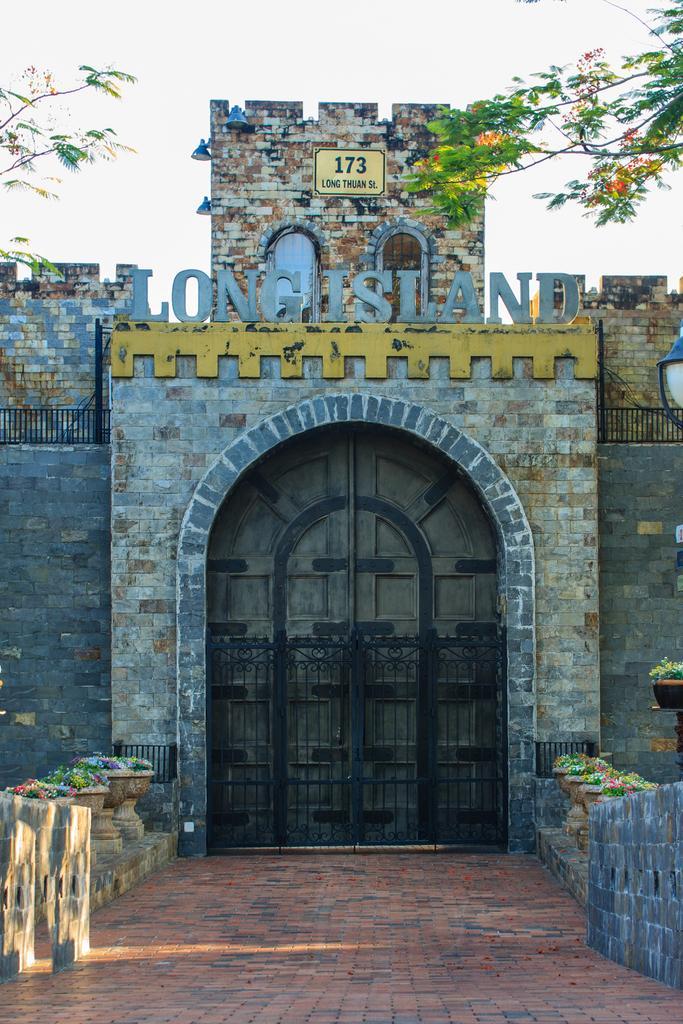How would you summarize this image in a sentence or two? In this image we can see a wall with gate and doors. In front of the gate we can see walkway, houseplants and a wall. At the top we can see a tree and the sky. 